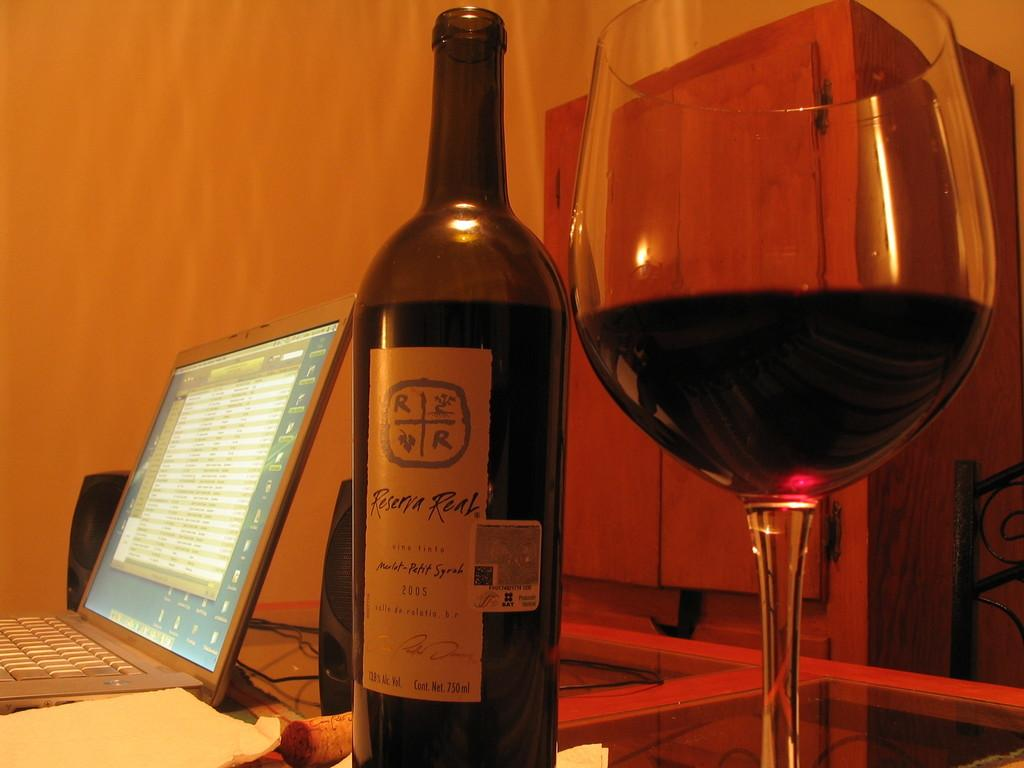<image>
Describe the image concisely. A bottle of Reserva Real wine sits next to a partially full wine glass and a laptop computer. 